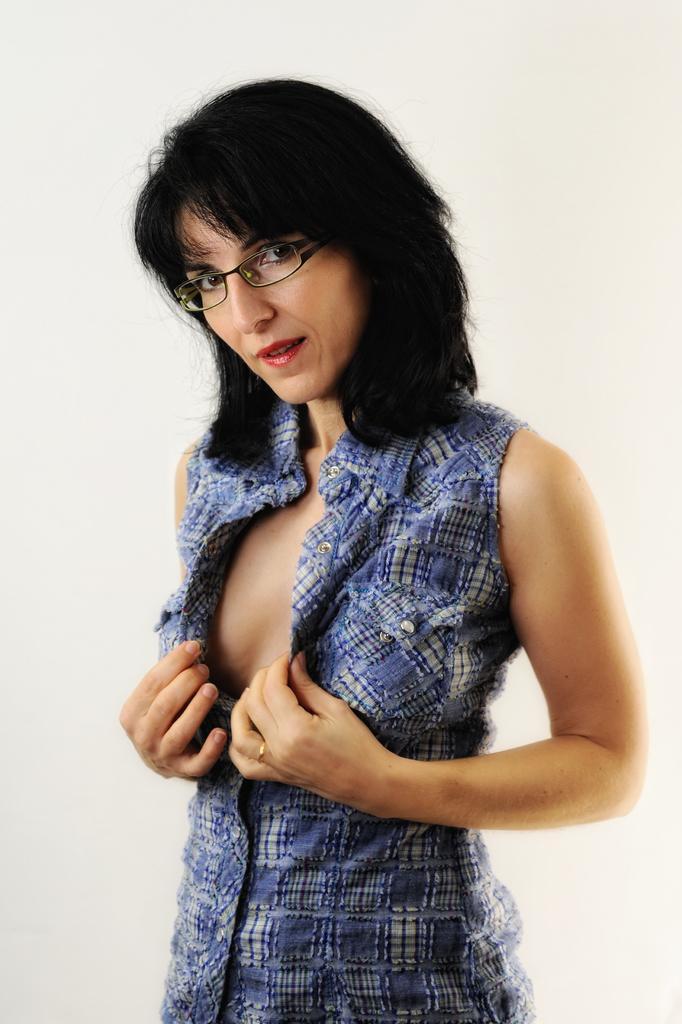Please provide a concise description of this image. In this image a woman is standing and she is with a short hair. She has worn a skirt and spectacles. 